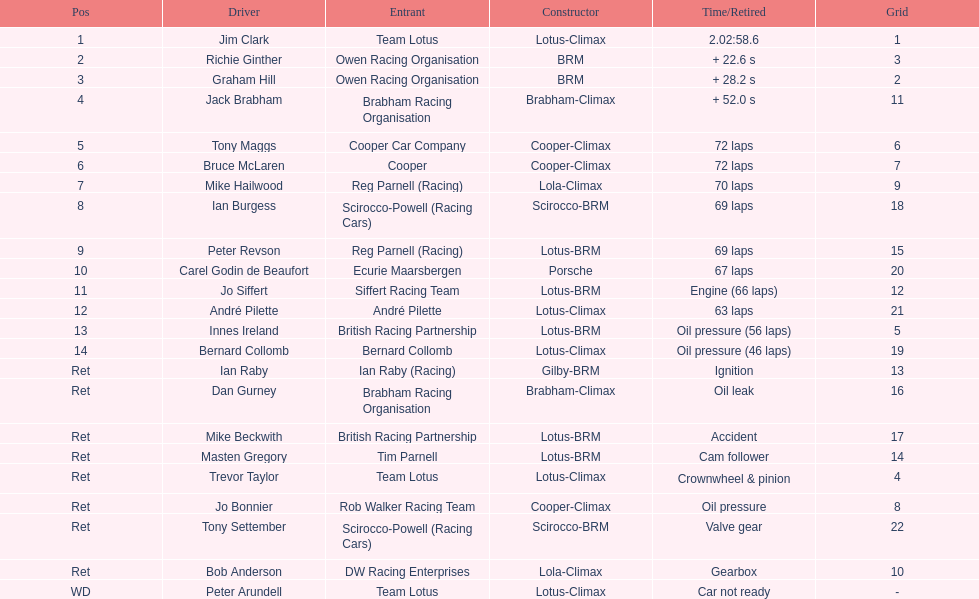Who arrived in first place? Jim Clark. 